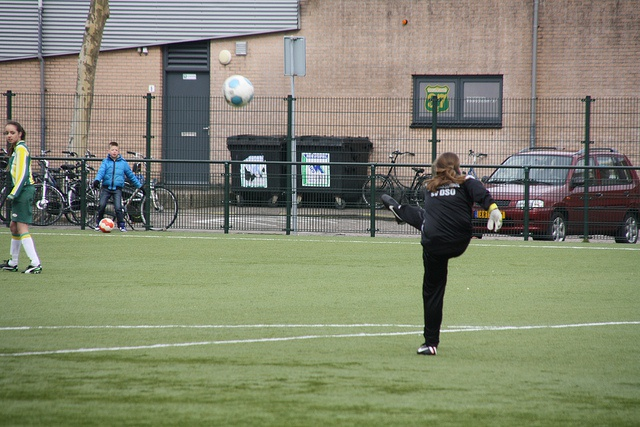Describe the objects in this image and their specific colors. I can see car in gray, black, darkgray, and maroon tones, people in gray, black, and maroon tones, people in gray, teal, black, lightgray, and darkgray tones, bicycle in gray, black, teal, and darkgray tones, and bicycle in gray, black, purple, and darkgray tones in this image. 